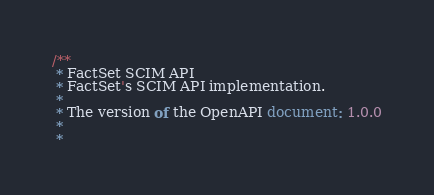Convert code to text. <code><loc_0><loc_0><loc_500><loc_500><_JavaScript_>/**
 * FactSet SCIM API
 * FactSet's SCIM API implementation.
 *
 * The version of the OpenAPI document: 1.0.0
 * 
 *</code> 